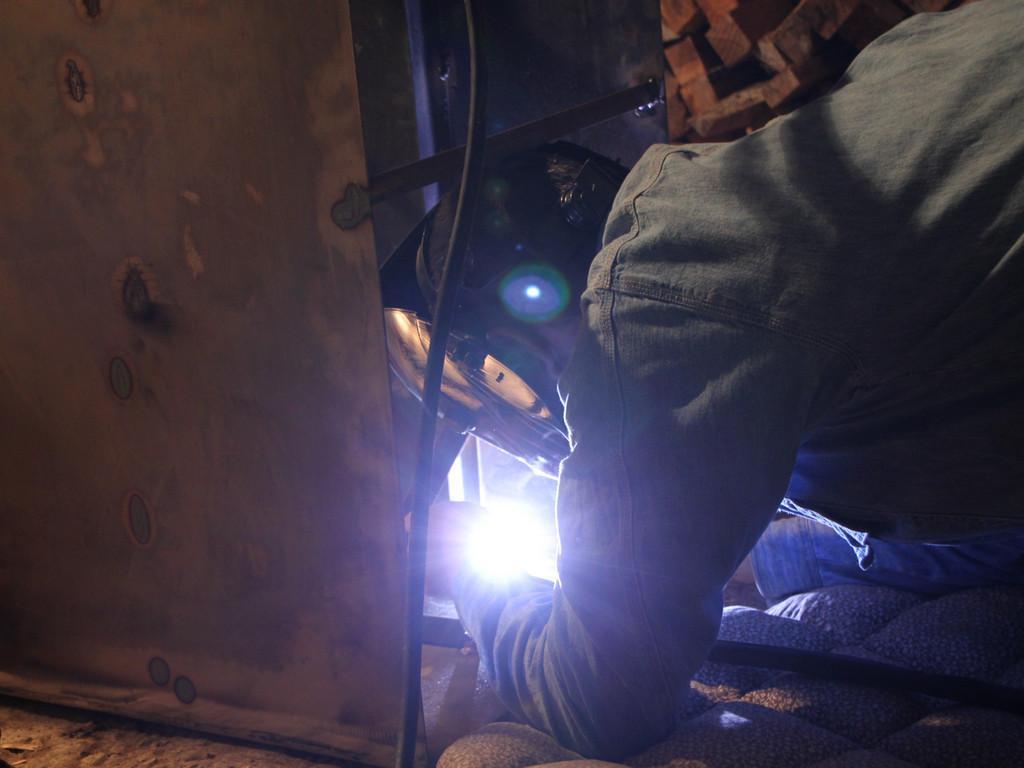Could you give a brief overview of what you see in this image? As we can see in the image on the right side there is a man. In the middle there is an electrical equipment and light. On the left side there is a cloth. 